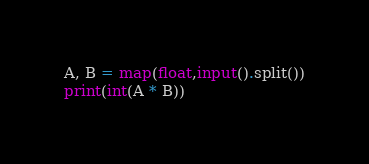Convert code to text. <code><loc_0><loc_0><loc_500><loc_500><_Python_>A, B = map(float,input().split())
print(int(A * B))</code> 